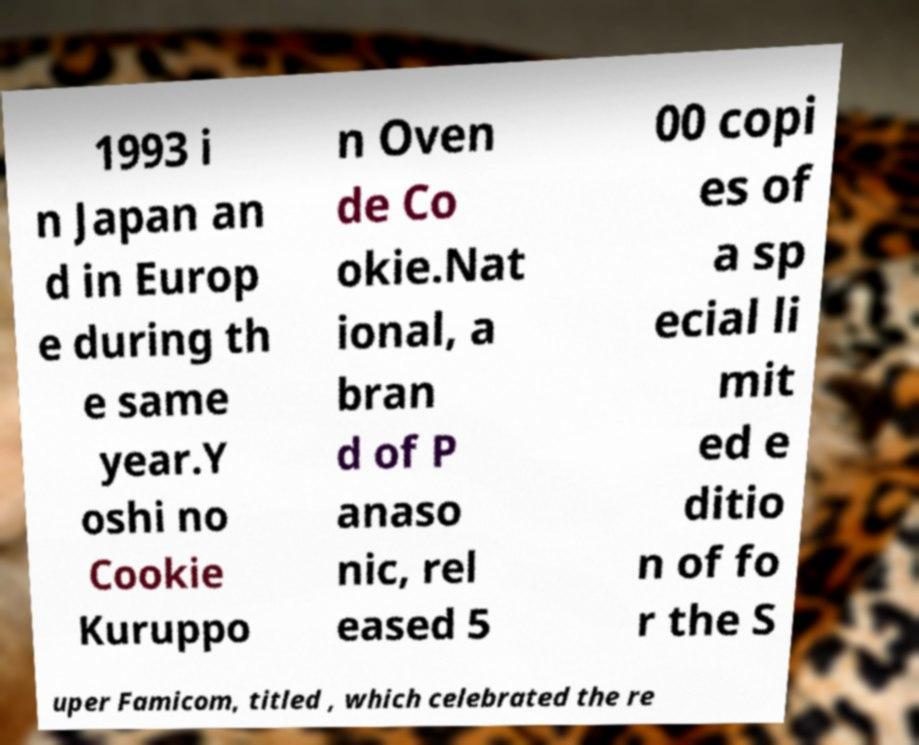Can you accurately transcribe the text from the provided image for me? 1993 i n Japan an d in Europ e during th e same year.Y oshi no Cookie Kuruppo n Oven de Co okie.Nat ional, a bran d of P anaso nic, rel eased 5 00 copi es of a sp ecial li mit ed e ditio n of fo r the S uper Famicom, titled , which celebrated the re 